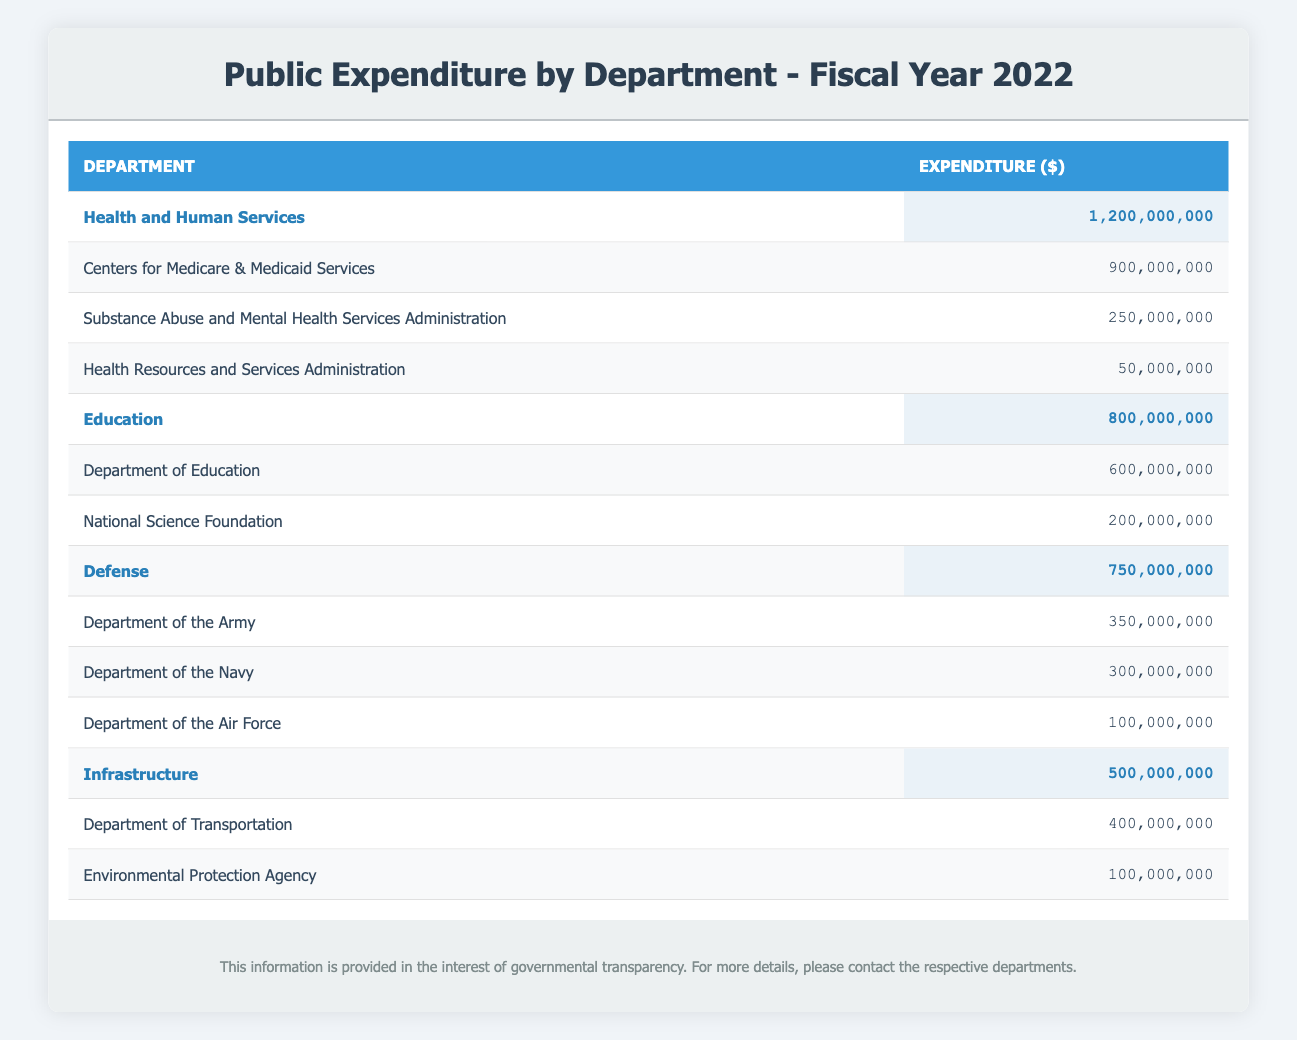What is the total expenditure for the Health and Human Services department? The total expenditure for the Health and Human Services department is directly listed in the table as 1,200,000,000.
Answer: 1,200,000,000 How much did the Department of Education spend? The expenditure amount for the Department of Education is explicitly mentioned in the table as 600,000,000.
Answer: 600,000,000 Is the expenditure for the Department of the Navy greater than the expenditure for the Department of Transportation? The expenditure for the Department of the Navy is 300,000,000 and for the Department of Transportation is 400,000,000. Since 300,000,000 is not greater than 400,000,000, the answer is no.
Answer: No What is the total expenditure of the Defense department? The total expenditure for the Defense department is shown in the table as 750,000,000, combining the expenditures of its sub-departments. This number is a direct value from the table.
Answer: 750,000,000 What is the total expenditure for all departments combined? To find the total expenditure for all departments, add the total expenditures of each department: 1,200,000,000 (Health) + 800,000,000 (Education) + 750,000,000 (Defense) + 500,000,000 (Infrastructure) = 3,250,000,000. Therefore, the total is obtained by summing these values.
Answer: 3,250,000,000 Which department has the largest total expenditure? By comparing the total expenditure values listed for each department in the table, Health and Human Services has the largest expenditure at 1,200,000,000.
Answer: Health and Human Services What is the average expenditure of all sub-departments under the Health and Human Services department? The total expenditure for Health and Human Services is 1,200,000,000 divided by the number of sub-departments, which is 3. The average is calculated as 1,200,000,000 / 3 = 400,000,000.
Answer: 400,000,000 Is the expenditure for the Environmental Protection Agency higher than that of the Substance Abuse and Mental Health Services Administration? The expenditure of the Environmental Protection Agency is 100,000,000 while that of the Substance Abuse and Mental Health Services Administration is 250,000,000. Since 100,000,000 is less than 250,000,000, the answer is no.
Answer: No What is the combined expenditure of all the sub-departments under Education? The total expenditure for the Education department is found by adding the expenditures of its sub-departments: 600,000,000 (Department of Education) + 200,000,000 (National Science Foundation) = 800,000,000, which matches the total expenditure for the Education department.
Answer: 800,000,000 